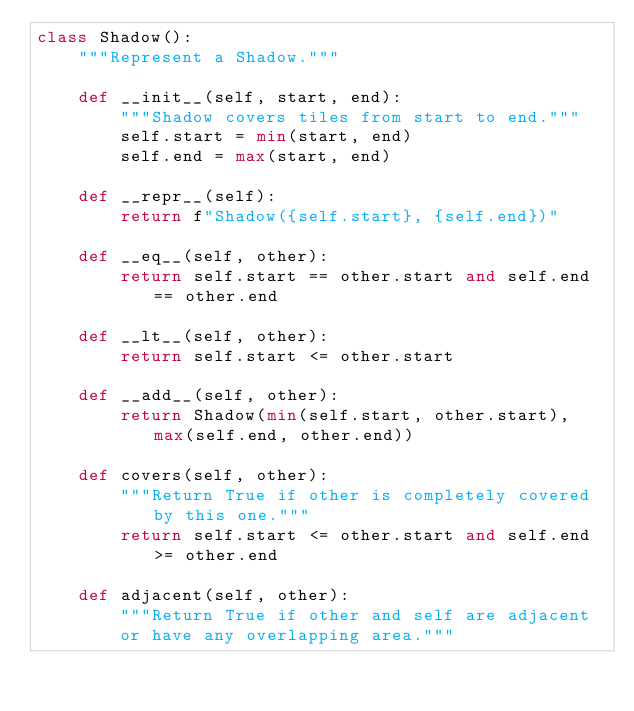<code> <loc_0><loc_0><loc_500><loc_500><_Python_>class Shadow():
    """Represent a Shadow."""

    def __init__(self, start, end):
        """Shadow covers tiles from start to end."""
        self.start = min(start, end)
        self.end = max(start, end)

    def __repr__(self):
        return f"Shadow({self.start}, {self.end})"

    def __eq__(self, other):
        return self.start == other.start and self.end == other.end

    def __lt__(self, other):
        return self.start <= other.start

    def __add__(self, other):
        return Shadow(min(self.start, other.start), max(self.end, other.end))

    def covers(self, other):
        """Return True if other is completely covered by this one."""
        return self.start <= other.start and self.end >= other.end

    def adjacent(self, other):
        """Return True if other and self are adjacent
        or have any overlapping area."""</code> 